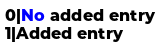<code> <loc_0><loc_0><loc_500><loc_500><_SQL_>0|No added entry 
1|Added entry </code> 